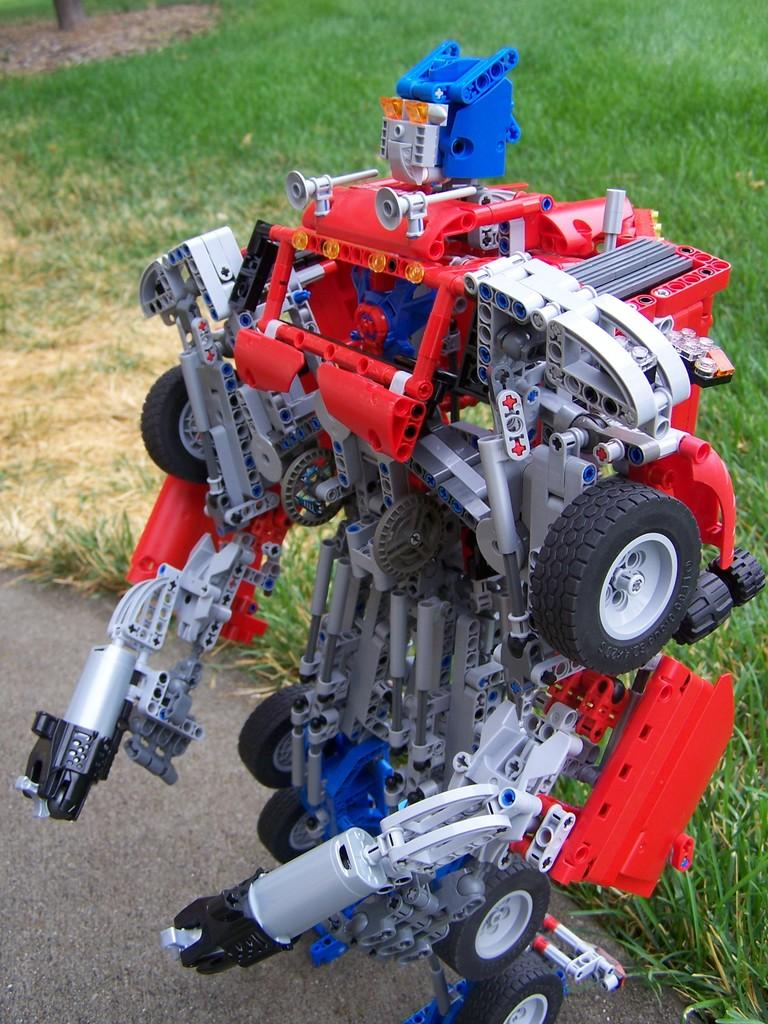What is the main subject of the image? There is a robot in the image. Can you describe the colors of the robot? The robot is red, blue, ash, and black in color. What material is the robot made of? The robot is made of plastic. Where is the robot located in the image? The robot is on the ground. What can be seen in the background of the image? There is grass visible in the background of the image. Can you tell me how many spots are on the goose in the image? There is no goose present in the image, and therefore no spots can be observed. What type of bat is flying near the robot in the image? There is no bat present in the image; the main subject is the robot. 